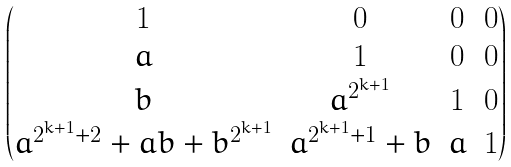<formula> <loc_0><loc_0><loc_500><loc_500>\begin{pmatrix} 1 & 0 & 0 & 0 \\ a & 1 & 0 & 0 \\ b & a ^ { 2 ^ { k + 1 } } & 1 & 0 \\ a ^ { 2 ^ { k + 1 } + 2 } + a b + b ^ { 2 ^ { k + 1 } } & a ^ { 2 ^ { k + 1 } + 1 } + b & a & 1 \end{pmatrix}</formula> 